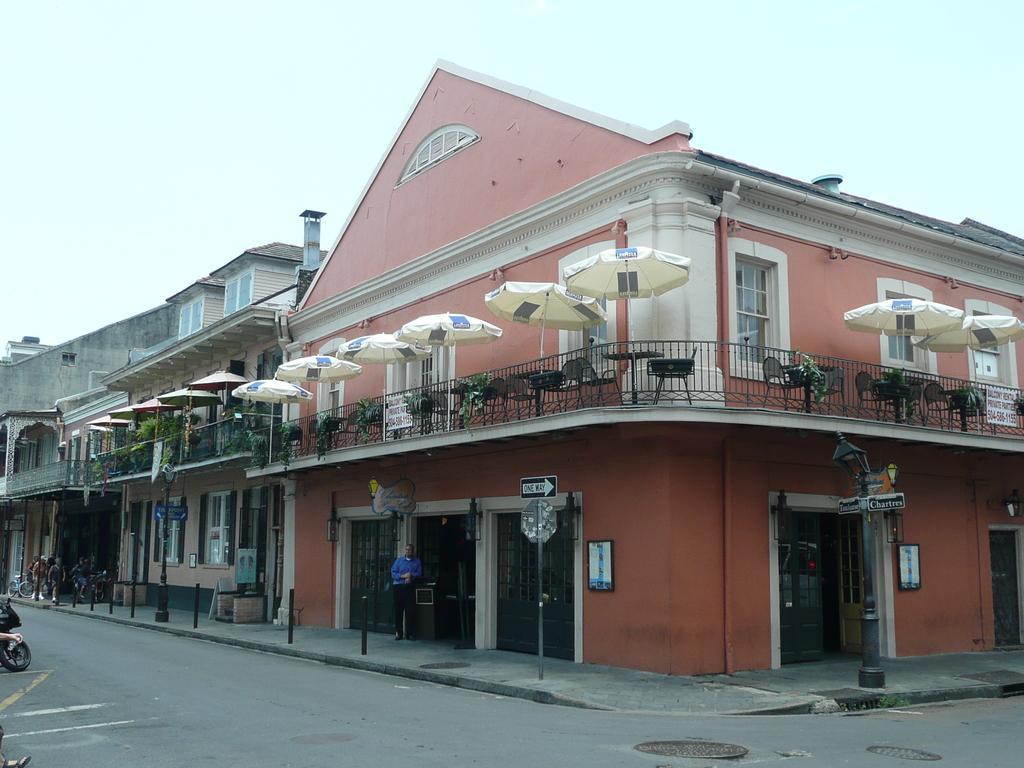How would you summarize this image in a sentence or two? In this picture there is a man who is standing near to the door, beside him i can see the sign boards. In the center i can see the bridge. On the first floor i can see the table, chairs and umbrella. On the left there are three persons were standing near to the bikes. At the top there is a sky. On the right there is a street lights in front of the door. 